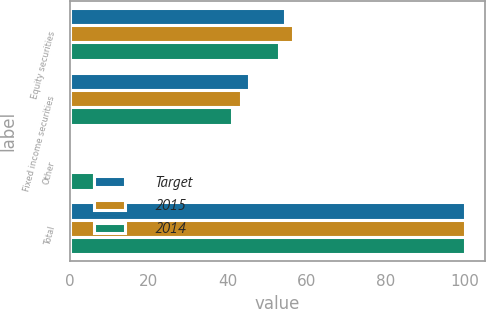<chart> <loc_0><loc_0><loc_500><loc_500><stacked_bar_chart><ecel><fcel>Equity securities<fcel>Fixed income securities<fcel>Other<fcel>Total<nl><fcel>Target<fcel>54.4<fcel>45.3<fcel>0.3<fcel>100<nl><fcel>2015<fcel>56.6<fcel>43.2<fcel>0.2<fcel>100<nl><fcel>2014<fcel>53<fcel>41<fcel>6<fcel>100<nl></chart> 